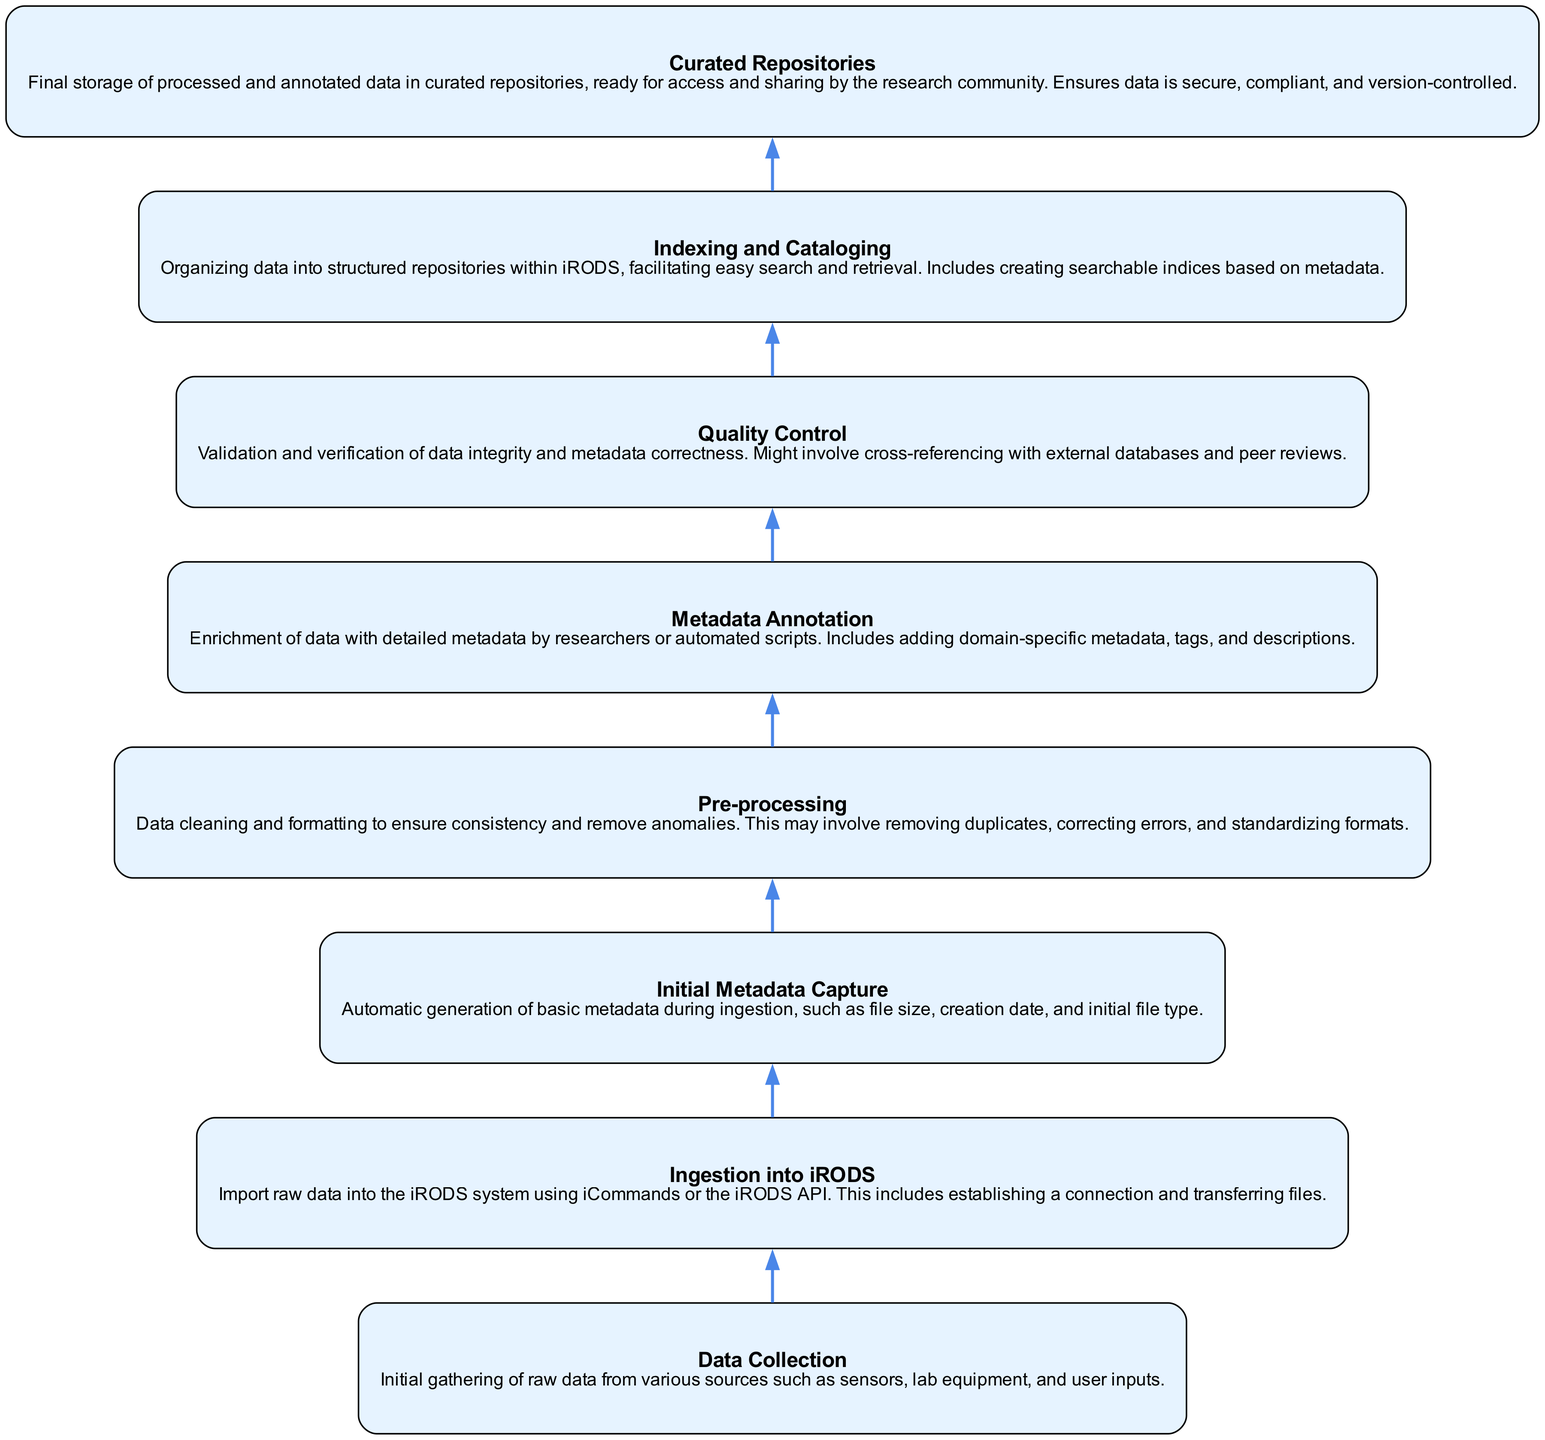What is the first step in the process? The first step is indicated at the bottom of the diagram and is labeled "Data Collection," which involves gathering raw data from various sources.
Answer: Data Collection How many total steps are there in the process? To determine the total number of steps, count the nodes displayed in the diagram. There are eight distinct elements in the process flow.
Answer: Eight Which step follows "Initial Metadata Capture"? Following the "Initial Metadata Capture" node, the next step in the process flow is "Pre-processing," where data is cleaned and formatted.
Answer: Pre-processing What type of operations are involved in the "Quality Control" step? The "Quality Control" step includes validation and verification operations, such as cross-referencing data integrity and checking metadata correctness.
Answer: Validation and verification What action is performed during the "Metadata Annotation" phase? During the "Metadata Annotation" phase, detailed metadata is added to the data, ensuring it is enriched with domain-specific information and tags.
Answer: Add detailed metadata Which node connects "Pre-processing" to "Quality Control"? The node that connects "Pre-processing" to "Quality Control" is "Metadata Annotation," indicating that after pre-processing, metadata is annotated before quality control takes place.
Answer: Metadata Annotation What is the final destination of the processed data? At the top of the diagram, it indicates that the final destination of the processed data is "Curated Repositories," where the data is stored for access and sharing.
Answer: Curated Repositories Which two elements are directly related to data organization within iRODS? The two elements directly involved in data organization within iRODS are "Indexing and Cataloging" and "Curated Repositories." Both steps relate to structuring and securing data storage.
Answer: Indexing and Cataloging; Curated Repositories 